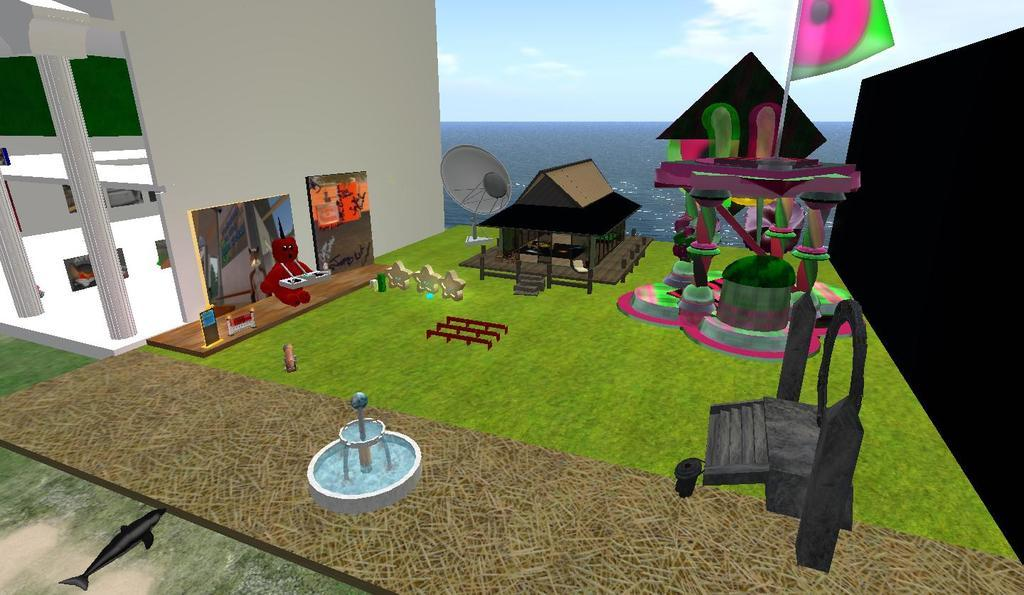What type of image is being described? The image is animated. What structure can be seen in the image? There is a house in the image. What additional feature is present in the image? There is a garden in the image. Can you describe another element in the image? There is a fountain in the image. What other items are present in the image? There are other items in the image, but their specific details are not mentioned in the facts. What can be seen in the background of the image? There is a sea and the sky visible in the background of the image. What is the desire of the circle in the image? There is no circle present in the image, so it is not possible to determine its desires. 